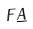<formula> <loc_0><loc_0><loc_500><loc_500>F \underline { A }</formula> 